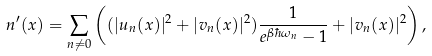Convert formula to latex. <formula><loc_0><loc_0><loc_500><loc_500>n ^ { \prime } ( { x } ) = \sum _ { { n } \neq { 0 } } \left ( ( | u _ { n } ( { x } ) | ^ { 2 } + | v _ { n } ( { x } ) | ^ { 2 } ) \frac { 1 } { e ^ { \beta \hbar { \omega } _ { n } } - 1 } + | v _ { n } ( { x } ) | ^ { 2 } \right ) ,</formula> 